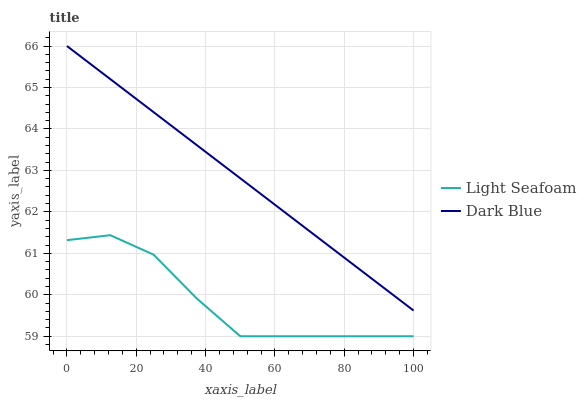Does Light Seafoam have the minimum area under the curve?
Answer yes or no. Yes. Does Dark Blue have the maximum area under the curve?
Answer yes or no. Yes. Does Light Seafoam have the maximum area under the curve?
Answer yes or no. No. Is Dark Blue the smoothest?
Answer yes or no. Yes. Is Light Seafoam the roughest?
Answer yes or no. Yes. Is Light Seafoam the smoothest?
Answer yes or no. No. Does Light Seafoam have the lowest value?
Answer yes or no. Yes. Does Dark Blue have the highest value?
Answer yes or no. Yes. Does Light Seafoam have the highest value?
Answer yes or no. No. Is Light Seafoam less than Dark Blue?
Answer yes or no. Yes. Is Dark Blue greater than Light Seafoam?
Answer yes or no. Yes. Does Light Seafoam intersect Dark Blue?
Answer yes or no. No. 